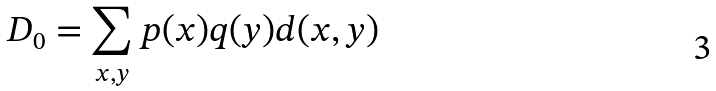Convert formula to latex. <formula><loc_0><loc_0><loc_500><loc_500>D _ { 0 } = \sum _ { x , y } p ( x ) q ( y ) d ( x , y )</formula> 